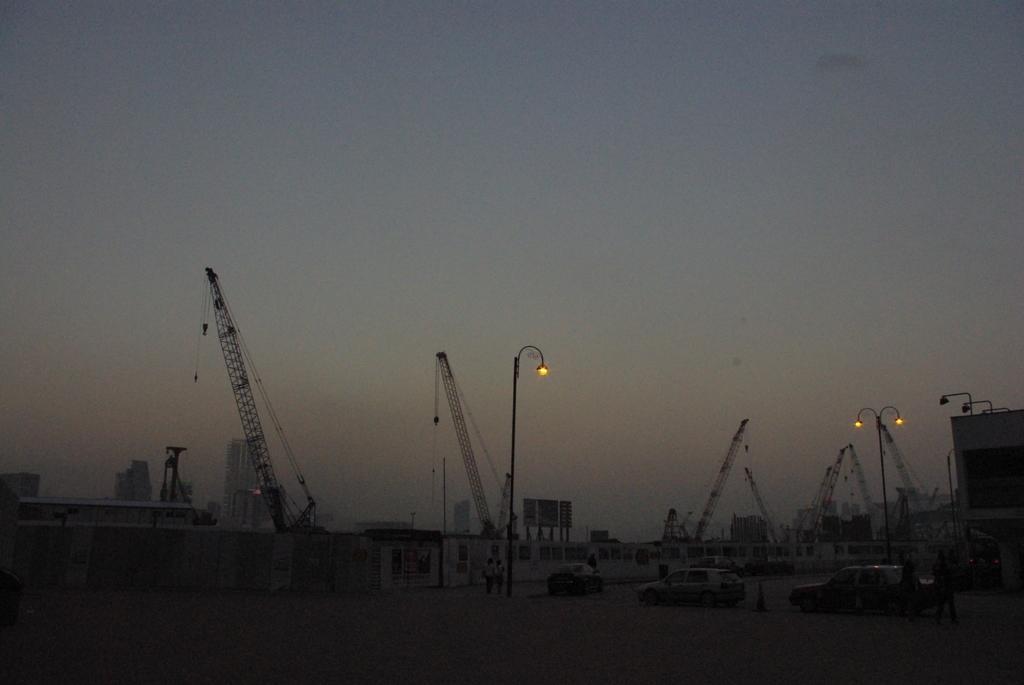Can you describe this image briefly? This image consists of many cranes. And we can see the poles along with the lamps. At the bottom, there is a road. And there are few persons in this image. In the front, there are cars parked. At the top, there is sky. 